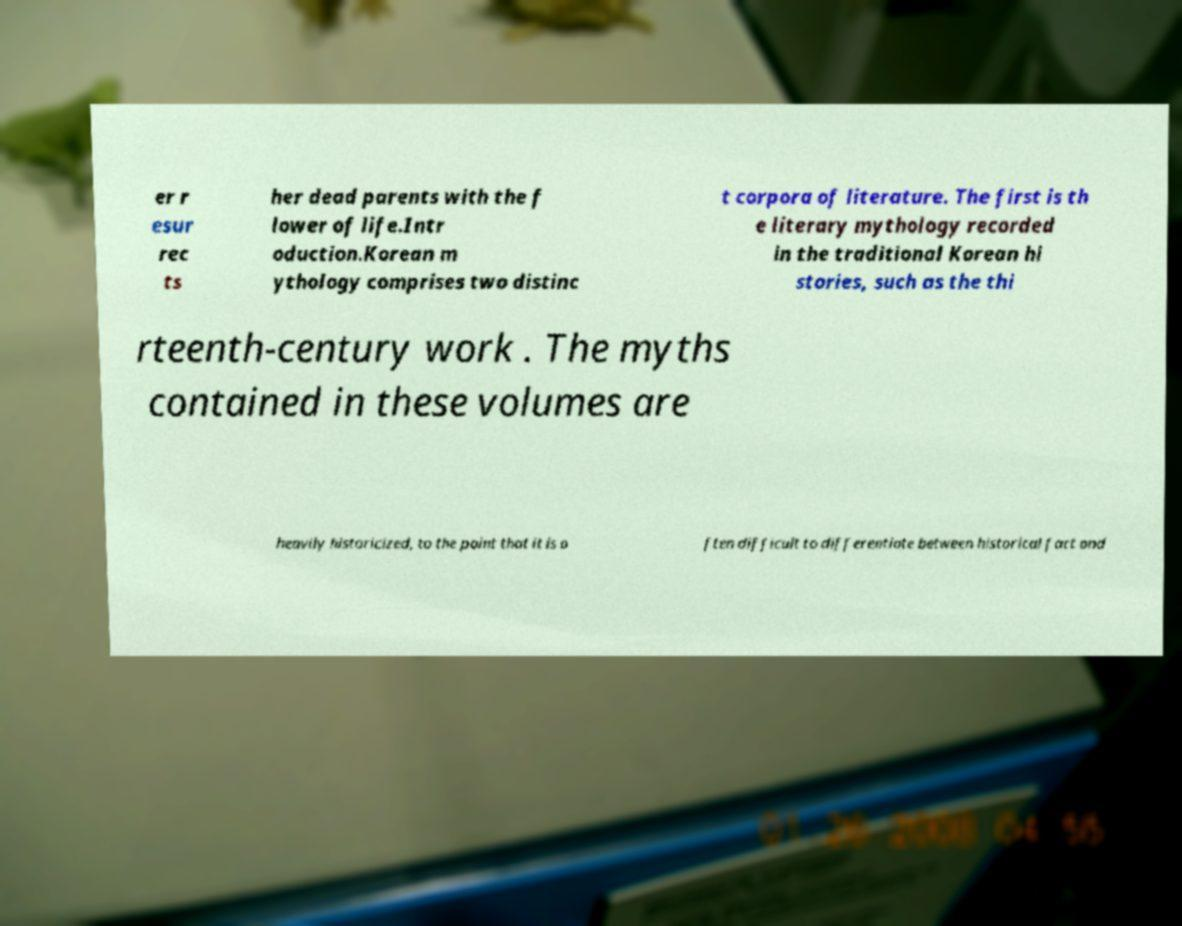Could you extract and type out the text from this image? er r esur rec ts her dead parents with the f lower of life.Intr oduction.Korean m ythology comprises two distinc t corpora of literature. The first is th e literary mythology recorded in the traditional Korean hi stories, such as the thi rteenth-century work . The myths contained in these volumes are heavily historicized, to the point that it is o ften difficult to differentiate between historical fact and 